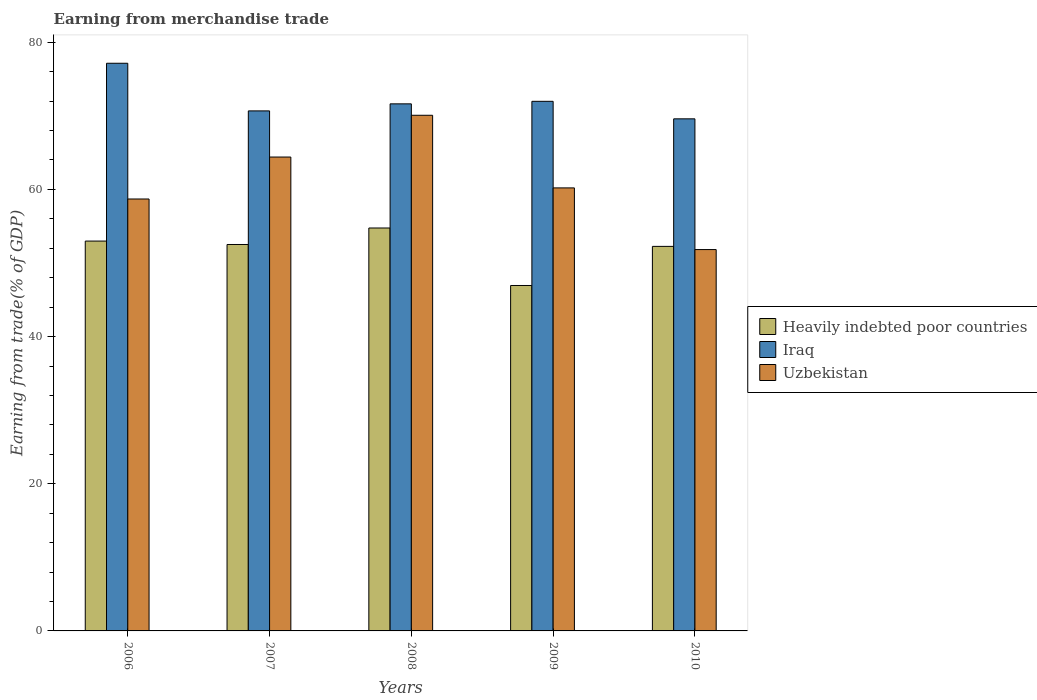How many different coloured bars are there?
Ensure brevity in your answer.  3. Are the number of bars on each tick of the X-axis equal?
Your response must be concise. Yes. In how many cases, is the number of bars for a given year not equal to the number of legend labels?
Your answer should be very brief. 0. What is the earnings from trade in Uzbekistan in 2008?
Provide a succinct answer. 70.08. Across all years, what is the maximum earnings from trade in Iraq?
Your answer should be compact. 77.15. Across all years, what is the minimum earnings from trade in Heavily indebted poor countries?
Give a very brief answer. 46.94. In which year was the earnings from trade in Heavily indebted poor countries minimum?
Make the answer very short. 2009. What is the total earnings from trade in Heavily indebted poor countries in the graph?
Provide a succinct answer. 259.46. What is the difference between the earnings from trade in Iraq in 2006 and that in 2009?
Ensure brevity in your answer.  5.17. What is the difference between the earnings from trade in Uzbekistan in 2008 and the earnings from trade in Heavily indebted poor countries in 2009?
Provide a short and direct response. 23.13. What is the average earnings from trade in Uzbekistan per year?
Offer a very short reply. 61.04. In the year 2007, what is the difference between the earnings from trade in Uzbekistan and earnings from trade in Iraq?
Your answer should be very brief. -6.27. In how many years, is the earnings from trade in Heavily indebted poor countries greater than 8 %?
Make the answer very short. 5. What is the ratio of the earnings from trade in Uzbekistan in 2008 to that in 2010?
Your response must be concise. 1.35. What is the difference between the highest and the second highest earnings from trade in Heavily indebted poor countries?
Offer a very short reply. 1.78. What is the difference between the highest and the lowest earnings from trade in Uzbekistan?
Your answer should be very brief. 18.25. Is the sum of the earnings from trade in Heavily indebted poor countries in 2006 and 2008 greater than the maximum earnings from trade in Iraq across all years?
Make the answer very short. Yes. What does the 1st bar from the left in 2010 represents?
Offer a very short reply. Heavily indebted poor countries. What does the 3rd bar from the right in 2008 represents?
Your answer should be very brief. Heavily indebted poor countries. How many bars are there?
Your answer should be compact. 15. How many years are there in the graph?
Your answer should be compact. 5. Are the values on the major ticks of Y-axis written in scientific E-notation?
Keep it short and to the point. No. Does the graph contain grids?
Give a very brief answer. No. Where does the legend appear in the graph?
Provide a short and direct response. Center right. How many legend labels are there?
Provide a short and direct response. 3. What is the title of the graph?
Offer a very short reply. Earning from merchandise trade. Does "Jordan" appear as one of the legend labels in the graph?
Ensure brevity in your answer.  No. What is the label or title of the Y-axis?
Give a very brief answer. Earning from trade(% of GDP). What is the Earning from trade(% of GDP) of Heavily indebted poor countries in 2006?
Ensure brevity in your answer.  52.98. What is the Earning from trade(% of GDP) of Iraq in 2006?
Offer a very short reply. 77.15. What is the Earning from trade(% of GDP) in Uzbekistan in 2006?
Make the answer very short. 58.7. What is the Earning from trade(% of GDP) in Heavily indebted poor countries in 2007?
Give a very brief answer. 52.52. What is the Earning from trade(% of GDP) of Iraq in 2007?
Your answer should be very brief. 70.67. What is the Earning from trade(% of GDP) of Uzbekistan in 2007?
Your answer should be compact. 64.4. What is the Earning from trade(% of GDP) of Heavily indebted poor countries in 2008?
Your response must be concise. 54.76. What is the Earning from trade(% of GDP) in Iraq in 2008?
Your response must be concise. 71.63. What is the Earning from trade(% of GDP) of Uzbekistan in 2008?
Offer a terse response. 70.08. What is the Earning from trade(% of GDP) of Heavily indebted poor countries in 2009?
Ensure brevity in your answer.  46.94. What is the Earning from trade(% of GDP) in Iraq in 2009?
Offer a very short reply. 71.97. What is the Earning from trade(% of GDP) of Uzbekistan in 2009?
Offer a very short reply. 60.21. What is the Earning from trade(% of GDP) of Heavily indebted poor countries in 2010?
Keep it short and to the point. 52.26. What is the Earning from trade(% of GDP) in Iraq in 2010?
Offer a very short reply. 69.59. What is the Earning from trade(% of GDP) in Uzbekistan in 2010?
Your answer should be compact. 51.83. Across all years, what is the maximum Earning from trade(% of GDP) of Heavily indebted poor countries?
Offer a terse response. 54.76. Across all years, what is the maximum Earning from trade(% of GDP) of Iraq?
Your answer should be very brief. 77.15. Across all years, what is the maximum Earning from trade(% of GDP) in Uzbekistan?
Your answer should be compact. 70.08. Across all years, what is the minimum Earning from trade(% of GDP) of Heavily indebted poor countries?
Your response must be concise. 46.94. Across all years, what is the minimum Earning from trade(% of GDP) of Iraq?
Make the answer very short. 69.59. Across all years, what is the minimum Earning from trade(% of GDP) in Uzbekistan?
Give a very brief answer. 51.83. What is the total Earning from trade(% of GDP) of Heavily indebted poor countries in the graph?
Offer a very short reply. 259.46. What is the total Earning from trade(% of GDP) in Iraq in the graph?
Offer a very short reply. 361.01. What is the total Earning from trade(% of GDP) of Uzbekistan in the graph?
Offer a terse response. 305.21. What is the difference between the Earning from trade(% of GDP) in Heavily indebted poor countries in 2006 and that in 2007?
Keep it short and to the point. 0.46. What is the difference between the Earning from trade(% of GDP) of Iraq in 2006 and that in 2007?
Make the answer very short. 6.47. What is the difference between the Earning from trade(% of GDP) in Uzbekistan in 2006 and that in 2007?
Offer a terse response. -5.7. What is the difference between the Earning from trade(% of GDP) of Heavily indebted poor countries in 2006 and that in 2008?
Give a very brief answer. -1.78. What is the difference between the Earning from trade(% of GDP) in Iraq in 2006 and that in 2008?
Make the answer very short. 5.52. What is the difference between the Earning from trade(% of GDP) in Uzbekistan in 2006 and that in 2008?
Offer a very short reply. -11.38. What is the difference between the Earning from trade(% of GDP) in Heavily indebted poor countries in 2006 and that in 2009?
Your answer should be compact. 6.04. What is the difference between the Earning from trade(% of GDP) in Iraq in 2006 and that in 2009?
Make the answer very short. 5.17. What is the difference between the Earning from trade(% of GDP) of Uzbekistan in 2006 and that in 2009?
Offer a terse response. -1.51. What is the difference between the Earning from trade(% of GDP) of Heavily indebted poor countries in 2006 and that in 2010?
Your response must be concise. 0.72. What is the difference between the Earning from trade(% of GDP) of Iraq in 2006 and that in 2010?
Give a very brief answer. 7.55. What is the difference between the Earning from trade(% of GDP) of Uzbekistan in 2006 and that in 2010?
Your answer should be very brief. 6.87. What is the difference between the Earning from trade(% of GDP) of Heavily indebted poor countries in 2007 and that in 2008?
Offer a very short reply. -2.24. What is the difference between the Earning from trade(% of GDP) in Iraq in 2007 and that in 2008?
Ensure brevity in your answer.  -0.96. What is the difference between the Earning from trade(% of GDP) of Uzbekistan in 2007 and that in 2008?
Your answer should be compact. -5.67. What is the difference between the Earning from trade(% of GDP) of Heavily indebted poor countries in 2007 and that in 2009?
Offer a very short reply. 5.57. What is the difference between the Earning from trade(% of GDP) of Iraq in 2007 and that in 2009?
Keep it short and to the point. -1.3. What is the difference between the Earning from trade(% of GDP) in Uzbekistan in 2007 and that in 2009?
Offer a very short reply. 4.19. What is the difference between the Earning from trade(% of GDP) of Heavily indebted poor countries in 2007 and that in 2010?
Keep it short and to the point. 0.26. What is the difference between the Earning from trade(% of GDP) in Iraq in 2007 and that in 2010?
Provide a succinct answer. 1.08. What is the difference between the Earning from trade(% of GDP) in Uzbekistan in 2007 and that in 2010?
Your response must be concise. 12.58. What is the difference between the Earning from trade(% of GDP) in Heavily indebted poor countries in 2008 and that in 2009?
Your answer should be compact. 7.81. What is the difference between the Earning from trade(% of GDP) of Iraq in 2008 and that in 2009?
Give a very brief answer. -0.34. What is the difference between the Earning from trade(% of GDP) of Uzbekistan in 2008 and that in 2009?
Provide a succinct answer. 9.87. What is the difference between the Earning from trade(% of GDP) in Heavily indebted poor countries in 2008 and that in 2010?
Give a very brief answer. 2.5. What is the difference between the Earning from trade(% of GDP) of Iraq in 2008 and that in 2010?
Ensure brevity in your answer.  2.04. What is the difference between the Earning from trade(% of GDP) in Uzbekistan in 2008 and that in 2010?
Your answer should be very brief. 18.25. What is the difference between the Earning from trade(% of GDP) of Heavily indebted poor countries in 2009 and that in 2010?
Your answer should be very brief. -5.31. What is the difference between the Earning from trade(% of GDP) of Iraq in 2009 and that in 2010?
Your answer should be compact. 2.38. What is the difference between the Earning from trade(% of GDP) of Uzbekistan in 2009 and that in 2010?
Offer a very short reply. 8.38. What is the difference between the Earning from trade(% of GDP) in Heavily indebted poor countries in 2006 and the Earning from trade(% of GDP) in Iraq in 2007?
Ensure brevity in your answer.  -17.69. What is the difference between the Earning from trade(% of GDP) in Heavily indebted poor countries in 2006 and the Earning from trade(% of GDP) in Uzbekistan in 2007?
Your answer should be compact. -11.42. What is the difference between the Earning from trade(% of GDP) of Iraq in 2006 and the Earning from trade(% of GDP) of Uzbekistan in 2007?
Offer a terse response. 12.74. What is the difference between the Earning from trade(% of GDP) of Heavily indebted poor countries in 2006 and the Earning from trade(% of GDP) of Iraq in 2008?
Offer a terse response. -18.65. What is the difference between the Earning from trade(% of GDP) of Heavily indebted poor countries in 2006 and the Earning from trade(% of GDP) of Uzbekistan in 2008?
Your answer should be compact. -17.09. What is the difference between the Earning from trade(% of GDP) of Iraq in 2006 and the Earning from trade(% of GDP) of Uzbekistan in 2008?
Offer a terse response. 7.07. What is the difference between the Earning from trade(% of GDP) in Heavily indebted poor countries in 2006 and the Earning from trade(% of GDP) in Iraq in 2009?
Offer a terse response. -18.99. What is the difference between the Earning from trade(% of GDP) of Heavily indebted poor countries in 2006 and the Earning from trade(% of GDP) of Uzbekistan in 2009?
Your response must be concise. -7.23. What is the difference between the Earning from trade(% of GDP) of Iraq in 2006 and the Earning from trade(% of GDP) of Uzbekistan in 2009?
Offer a very short reply. 16.94. What is the difference between the Earning from trade(% of GDP) of Heavily indebted poor countries in 2006 and the Earning from trade(% of GDP) of Iraq in 2010?
Keep it short and to the point. -16.61. What is the difference between the Earning from trade(% of GDP) of Heavily indebted poor countries in 2006 and the Earning from trade(% of GDP) of Uzbekistan in 2010?
Your answer should be compact. 1.16. What is the difference between the Earning from trade(% of GDP) of Iraq in 2006 and the Earning from trade(% of GDP) of Uzbekistan in 2010?
Provide a succinct answer. 25.32. What is the difference between the Earning from trade(% of GDP) in Heavily indebted poor countries in 2007 and the Earning from trade(% of GDP) in Iraq in 2008?
Offer a very short reply. -19.11. What is the difference between the Earning from trade(% of GDP) in Heavily indebted poor countries in 2007 and the Earning from trade(% of GDP) in Uzbekistan in 2008?
Offer a very short reply. -17.56. What is the difference between the Earning from trade(% of GDP) of Iraq in 2007 and the Earning from trade(% of GDP) of Uzbekistan in 2008?
Your answer should be compact. 0.59. What is the difference between the Earning from trade(% of GDP) in Heavily indebted poor countries in 2007 and the Earning from trade(% of GDP) in Iraq in 2009?
Ensure brevity in your answer.  -19.46. What is the difference between the Earning from trade(% of GDP) in Heavily indebted poor countries in 2007 and the Earning from trade(% of GDP) in Uzbekistan in 2009?
Keep it short and to the point. -7.69. What is the difference between the Earning from trade(% of GDP) of Iraq in 2007 and the Earning from trade(% of GDP) of Uzbekistan in 2009?
Your answer should be compact. 10.46. What is the difference between the Earning from trade(% of GDP) of Heavily indebted poor countries in 2007 and the Earning from trade(% of GDP) of Iraq in 2010?
Make the answer very short. -17.08. What is the difference between the Earning from trade(% of GDP) in Heavily indebted poor countries in 2007 and the Earning from trade(% of GDP) in Uzbekistan in 2010?
Offer a very short reply. 0.69. What is the difference between the Earning from trade(% of GDP) of Iraq in 2007 and the Earning from trade(% of GDP) of Uzbekistan in 2010?
Provide a succinct answer. 18.84. What is the difference between the Earning from trade(% of GDP) of Heavily indebted poor countries in 2008 and the Earning from trade(% of GDP) of Iraq in 2009?
Provide a short and direct response. -17.22. What is the difference between the Earning from trade(% of GDP) of Heavily indebted poor countries in 2008 and the Earning from trade(% of GDP) of Uzbekistan in 2009?
Your answer should be very brief. -5.45. What is the difference between the Earning from trade(% of GDP) of Iraq in 2008 and the Earning from trade(% of GDP) of Uzbekistan in 2009?
Your response must be concise. 11.42. What is the difference between the Earning from trade(% of GDP) of Heavily indebted poor countries in 2008 and the Earning from trade(% of GDP) of Iraq in 2010?
Make the answer very short. -14.84. What is the difference between the Earning from trade(% of GDP) of Heavily indebted poor countries in 2008 and the Earning from trade(% of GDP) of Uzbekistan in 2010?
Provide a succinct answer. 2.93. What is the difference between the Earning from trade(% of GDP) in Iraq in 2008 and the Earning from trade(% of GDP) in Uzbekistan in 2010?
Your answer should be very brief. 19.8. What is the difference between the Earning from trade(% of GDP) in Heavily indebted poor countries in 2009 and the Earning from trade(% of GDP) in Iraq in 2010?
Give a very brief answer. -22.65. What is the difference between the Earning from trade(% of GDP) of Heavily indebted poor countries in 2009 and the Earning from trade(% of GDP) of Uzbekistan in 2010?
Keep it short and to the point. -4.88. What is the difference between the Earning from trade(% of GDP) in Iraq in 2009 and the Earning from trade(% of GDP) in Uzbekistan in 2010?
Offer a very short reply. 20.15. What is the average Earning from trade(% of GDP) in Heavily indebted poor countries per year?
Provide a succinct answer. 51.89. What is the average Earning from trade(% of GDP) in Iraq per year?
Offer a very short reply. 72.2. What is the average Earning from trade(% of GDP) of Uzbekistan per year?
Your response must be concise. 61.04. In the year 2006, what is the difference between the Earning from trade(% of GDP) in Heavily indebted poor countries and Earning from trade(% of GDP) in Iraq?
Your answer should be very brief. -24.16. In the year 2006, what is the difference between the Earning from trade(% of GDP) in Heavily indebted poor countries and Earning from trade(% of GDP) in Uzbekistan?
Offer a terse response. -5.72. In the year 2006, what is the difference between the Earning from trade(% of GDP) of Iraq and Earning from trade(% of GDP) of Uzbekistan?
Make the answer very short. 18.45. In the year 2007, what is the difference between the Earning from trade(% of GDP) of Heavily indebted poor countries and Earning from trade(% of GDP) of Iraq?
Your response must be concise. -18.15. In the year 2007, what is the difference between the Earning from trade(% of GDP) in Heavily indebted poor countries and Earning from trade(% of GDP) in Uzbekistan?
Make the answer very short. -11.88. In the year 2007, what is the difference between the Earning from trade(% of GDP) of Iraq and Earning from trade(% of GDP) of Uzbekistan?
Provide a succinct answer. 6.27. In the year 2008, what is the difference between the Earning from trade(% of GDP) of Heavily indebted poor countries and Earning from trade(% of GDP) of Iraq?
Ensure brevity in your answer.  -16.87. In the year 2008, what is the difference between the Earning from trade(% of GDP) of Heavily indebted poor countries and Earning from trade(% of GDP) of Uzbekistan?
Your response must be concise. -15.32. In the year 2008, what is the difference between the Earning from trade(% of GDP) in Iraq and Earning from trade(% of GDP) in Uzbekistan?
Provide a short and direct response. 1.55. In the year 2009, what is the difference between the Earning from trade(% of GDP) in Heavily indebted poor countries and Earning from trade(% of GDP) in Iraq?
Offer a very short reply. -25.03. In the year 2009, what is the difference between the Earning from trade(% of GDP) of Heavily indebted poor countries and Earning from trade(% of GDP) of Uzbekistan?
Make the answer very short. -13.26. In the year 2009, what is the difference between the Earning from trade(% of GDP) in Iraq and Earning from trade(% of GDP) in Uzbekistan?
Your response must be concise. 11.77. In the year 2010, what is the difference between the Earning from trade(% of GDP) in Heavily indebted poor countries and Earning from trade(% of GDP) in Iraq?
Your answer should be compact. -17.33. In the year 2010, what is the difference between the Earning from trade(% of GDP) of Heavily indebted poor countries and Earning from trade(% of GDP) of Uzbekistan?
Make the answer very short. 0.43. In the year 2010, what is the difference between the Earning from trade(% of GDP) of Iraq and Earning from trade(% of GDP) of Uzbekistan?
Make the answer very short. 17.77. What is the ratio of the Earning from trade(% of GDP) of Heavily indebted poor countries in 2006 to that in 2007?
Make the answer very short. 1.01. What is the ratio of the Earning from trade(% of GDP) in Iraq in 2006 to that in 2007?
Make the answer very short. 1.09. What is the ratio of the Earning from trade(% of GDP) of Uzbekistan in 2006 to that in 2007?
Keep it short and to the point. 0.91. What is the ratio of the Earning from trade(% of GDP) of Heavily indebted poor countries in 2006 to that in 2008?
Offer a very short reply. 0.97. What is the ratio of the Earning from trade(% of GDP) in Iraq in 2006 to that in 2008?
Your answer should be compact. 1.08. What is the ratio of the Earning from trade(% of GDP) of Uzbekistan in 2006 to that in 2008?
Keep it short and to the point. 0.84. What is the ratio of the Earning from trade(% of GDP) of Heavily indebted poor countries in 2006 to that in 2009?
Ensure brevity in your answer.  1.13. What is the ratio of the Earning from trade(% of GDP) in Iraq in 2006 to that in 2009?
Make the answer very short. 1.07. What is the ratio of the Earning from trade(% of GDP) of Heavily indebted poor countries in 2006 to that in 2010?
Offer a very short reply. 1.01. What is the ratio of the Earning from trade(% of GDP) of Iraq in 2006 to that in 2010?
Your response must be concise. 1.11. What is the ratio of the Earning from trade(% of GDP) of Uzbekistan in 2006 to that in 2010?
Your answer should be compact. 1.13. What is the ratio of the Earning from trade(% of GDP) of Heavily indebted poor countries in 2007 to that in 2008?
Make the answer very short. 0.96. What is the ratio of the Earning from trade(% of GDP) in Iraq in 2007 to that in 2008?
Ensure brevity in your answer.  0.99. What is the ratio of the Earning from trade(% of GDP) in Uzbekistan in 2007 to that in 2008?
Offer a very short reply. 0.92. What is the ratio of the Earning from trade(% of GDP) of Heavily indebted poor countries in 2007 to that in 2009?
Offer a terse response. 1.12. What is the ratio of the Earning from trade(% of GDP) in Iraq in 2007 to that in 2009?
Provide a short and direct response. 0.98. What is the ratio of the Earning from trade(% of GDP) of Uzbekistan in 2007 to that in 2009?
Your response must be concise. 1.07. What is the ratio of the Earning from trade(% of GDP) of Iraq in 2007 to that in 2010?
Keep it short and to the point. 1.02. What is the ratio of the Earning from trade(% of GDP) in Uzbekistan in 2007 to that in 2010?
Your answer should be very brief. 1.24. What is the ratio of the Earning from trade(% of GDP) of Heavily indebted poor countries in 2008 to that in 2009?
Offer a very short reply. 1.17. What is the ratio of the Earning from trade(% of GDP) of Iraq in 2008 to that in 2009?
Ensure brevity in your answer.  1. What is the ratio of the Earning from trade(% of GDP) in Uzbekistan in 2008 to that in 2009?
Ensure brevity in your answer.  1.16. What is the ratio of the Earning from trade(% of GDP) of Heavily indebted poor countries in 2008 to that in 2010?
Your response must be concise. 1.05. What is the ratio of the Earning from trade(% of GDP) of Iraq in 2008 to that in 2010?
Your response must be concise. 1.03. What is the ratio of the Earning from trade(% of GDP) in Uzbekistan in 2008 to that in 2010?
Offer a very short reply. 1.35. What is the ratio of the Earning from trade(% of GDP) of Heavily indebted poor countries in 2009 to that in 2010?
Give a very brief answer. 0.9. What is the ratio of the Earning from trade(% of GDP) of Iraq in 2009 to that in 2010?
Keep it short and to the point. 1.03. What is the ratio of the Earning from trade(% of GDP) in Uzbekistan in 2009 to that in 2010?
Provide a short and direct response. 1.16. What is the difference between the highest and the second highest Earning from trade(% of GDP) of Heavily indebted poor countries?
Keep it short and to the point. 1.78. What is the difference between the highest and the second highest Earning from trade(% of GDP) in Iraq?
Your answer should be very brief. 5.17. What is the difference between the highest and the second highest Earning from trade(% of GDP) in Uzbekistan?
Keep it short and to the point. 5.67. What is the difference between the highest and the lowest Earning from trade(% of GDP) of Heavily indebted poor countries?
Keep it short and to the point. 7.81. What is the difference between the highest and the lowest Earning from trade(% of GDP) of Iraq?
Provide a succinct answer. 7.55. What is the difference between the highest and the lowest Earning from trade(% of GDP) of Uzbekistan?
Provide a succinct answer. 18.25. 